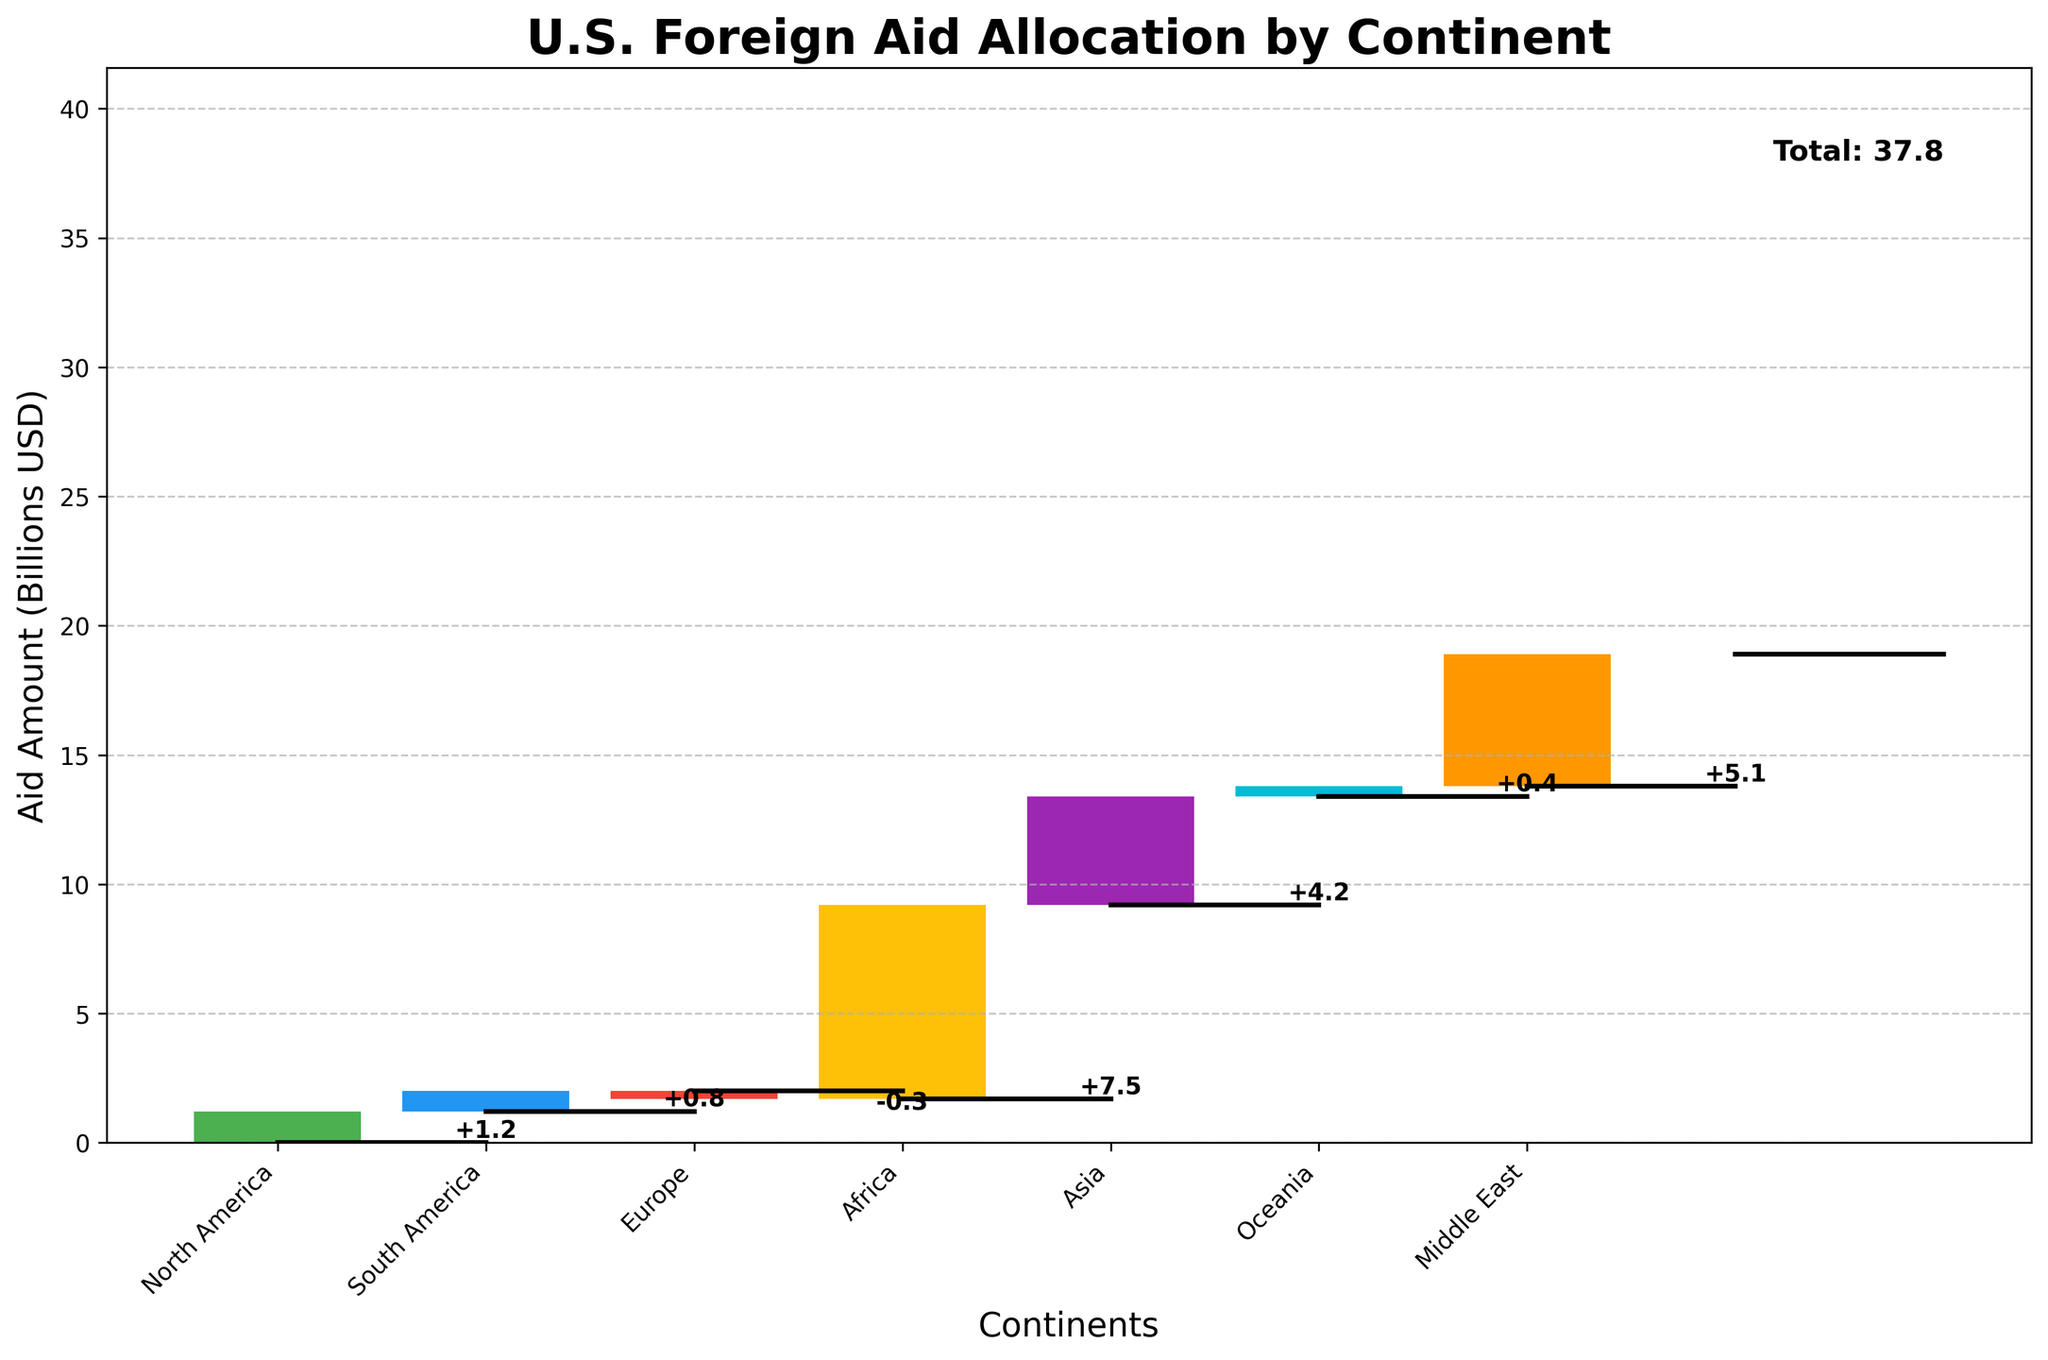What is the title of the chart? The title can be found at the top of the chart. It is "U.S. Foreign Aid Allocation by Continent".
Answer: U.S. Foreign Aid Allocation by Continent How much foreign aid does Africa receive? To find the foreign aid for Africa, look for the bar labeled "Africa" on the x-axis and read the value associated with it.
Answer: 7.5 billion USD Which continent has the smallest allocation of foreign aid? To identify the continent with the smallest allocation, compare the values of all continents, and find the one with the lowest positive or the highest negative value.
Answer: Europe How does the aid allocated to North America compare to that allocated to South America? Look at the values for North America and South America on the x-axis and compare them. North America has 1.2 billion USD and South America has 0.8 billion USD.
Answer: North America receives more aid than South America What is the total foreign aid allocation amount? The total foreign aid allocation is shown in the bar labeled "Total" at the end of the waterfall chart.
Answer: 18.9 billion USD What is the cumulative aid amount before Asia's allocation? To find the cumulative value before Asia’s allocation, sum the values from the start up to but not including Asia (0 + 1.2 + 0.8 - 0.3 + 7.5).
Answer: 9.2 billion USD Which continents receive more than 4 billion USD in foreign aid? Look at the values associated with each continent and filter out those greater than 4 billion USD. Africa (7.5), Asia (4.2), and the Middle East (5.1) are the ones exceeding 4 billion USD.
Answer: Africa, Asia, Middle East By how much does the foreign aid allocated to the Middle East exceed that allocated to Oceania? Subtract Oceania's value from the Middle East's value (5.1 - 0.4).
Answer: 4.7 billion USD What is the net contribution or withdrawal for Europe? Look at the value associated with the Europe bar and note whether it is positive (contribution) or negative (withdrawal). Europe has -0.3 billion USD, indicating a withdrawal.
Answer: -0.3 billion USD How does the aid allocated to Asia compare to Africa? Compare the values of foreign aid for Asia and Africa as seen on their respective bars. Africa receives 7.5 billion USD and Asia receives 4.2 billion USD.
Answer: Africa receives more aid than Asia 